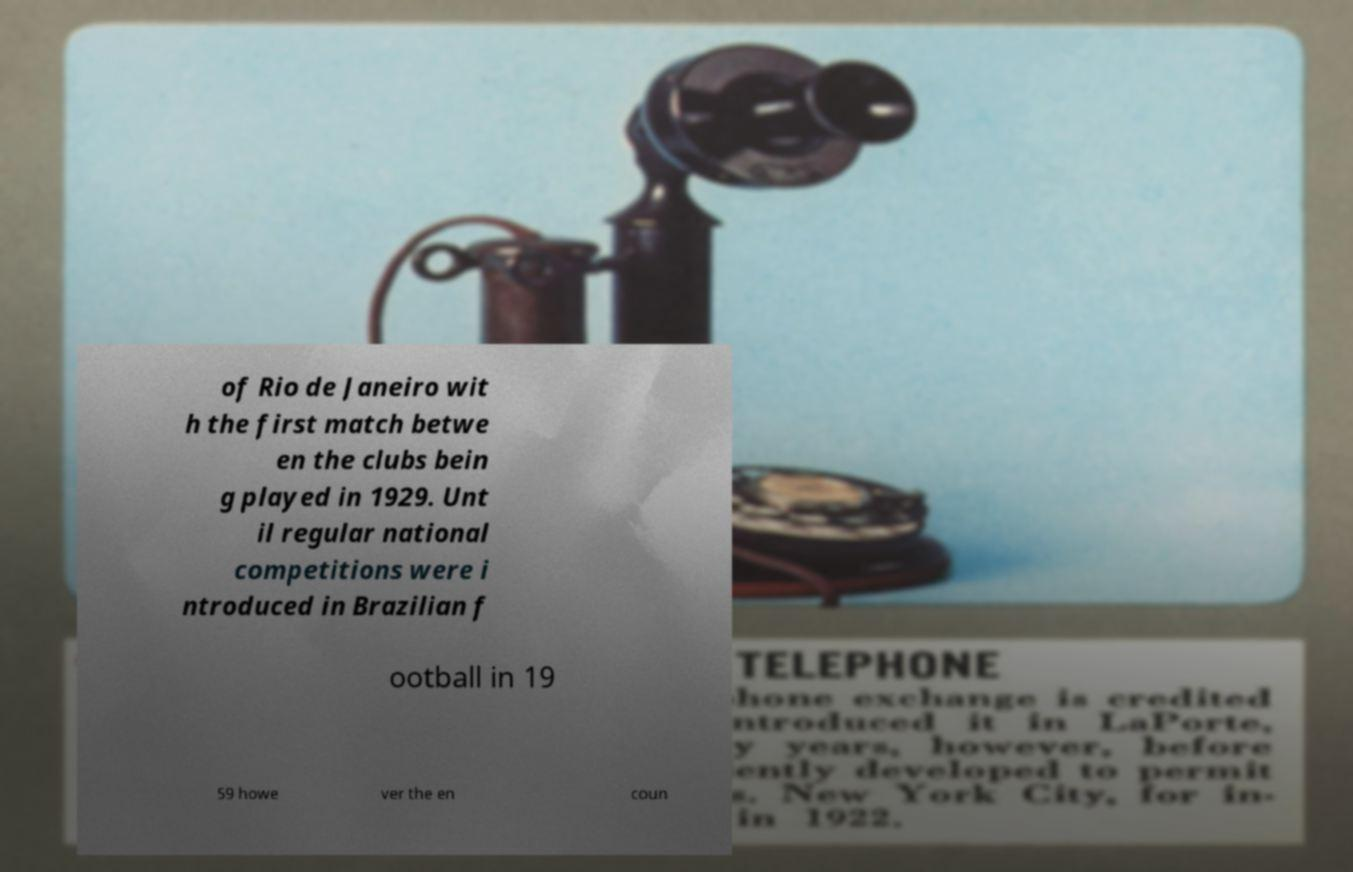There's text embedded in this image that I need extracted. Can you transcribe it verbatim? of Rio de Janeiro wit h the first match betwe en the clubs bein g played in 1929. Unt il regular national competitions were i ntroduced in Brazilian f ootball in 19 59 howe ver the en coun 